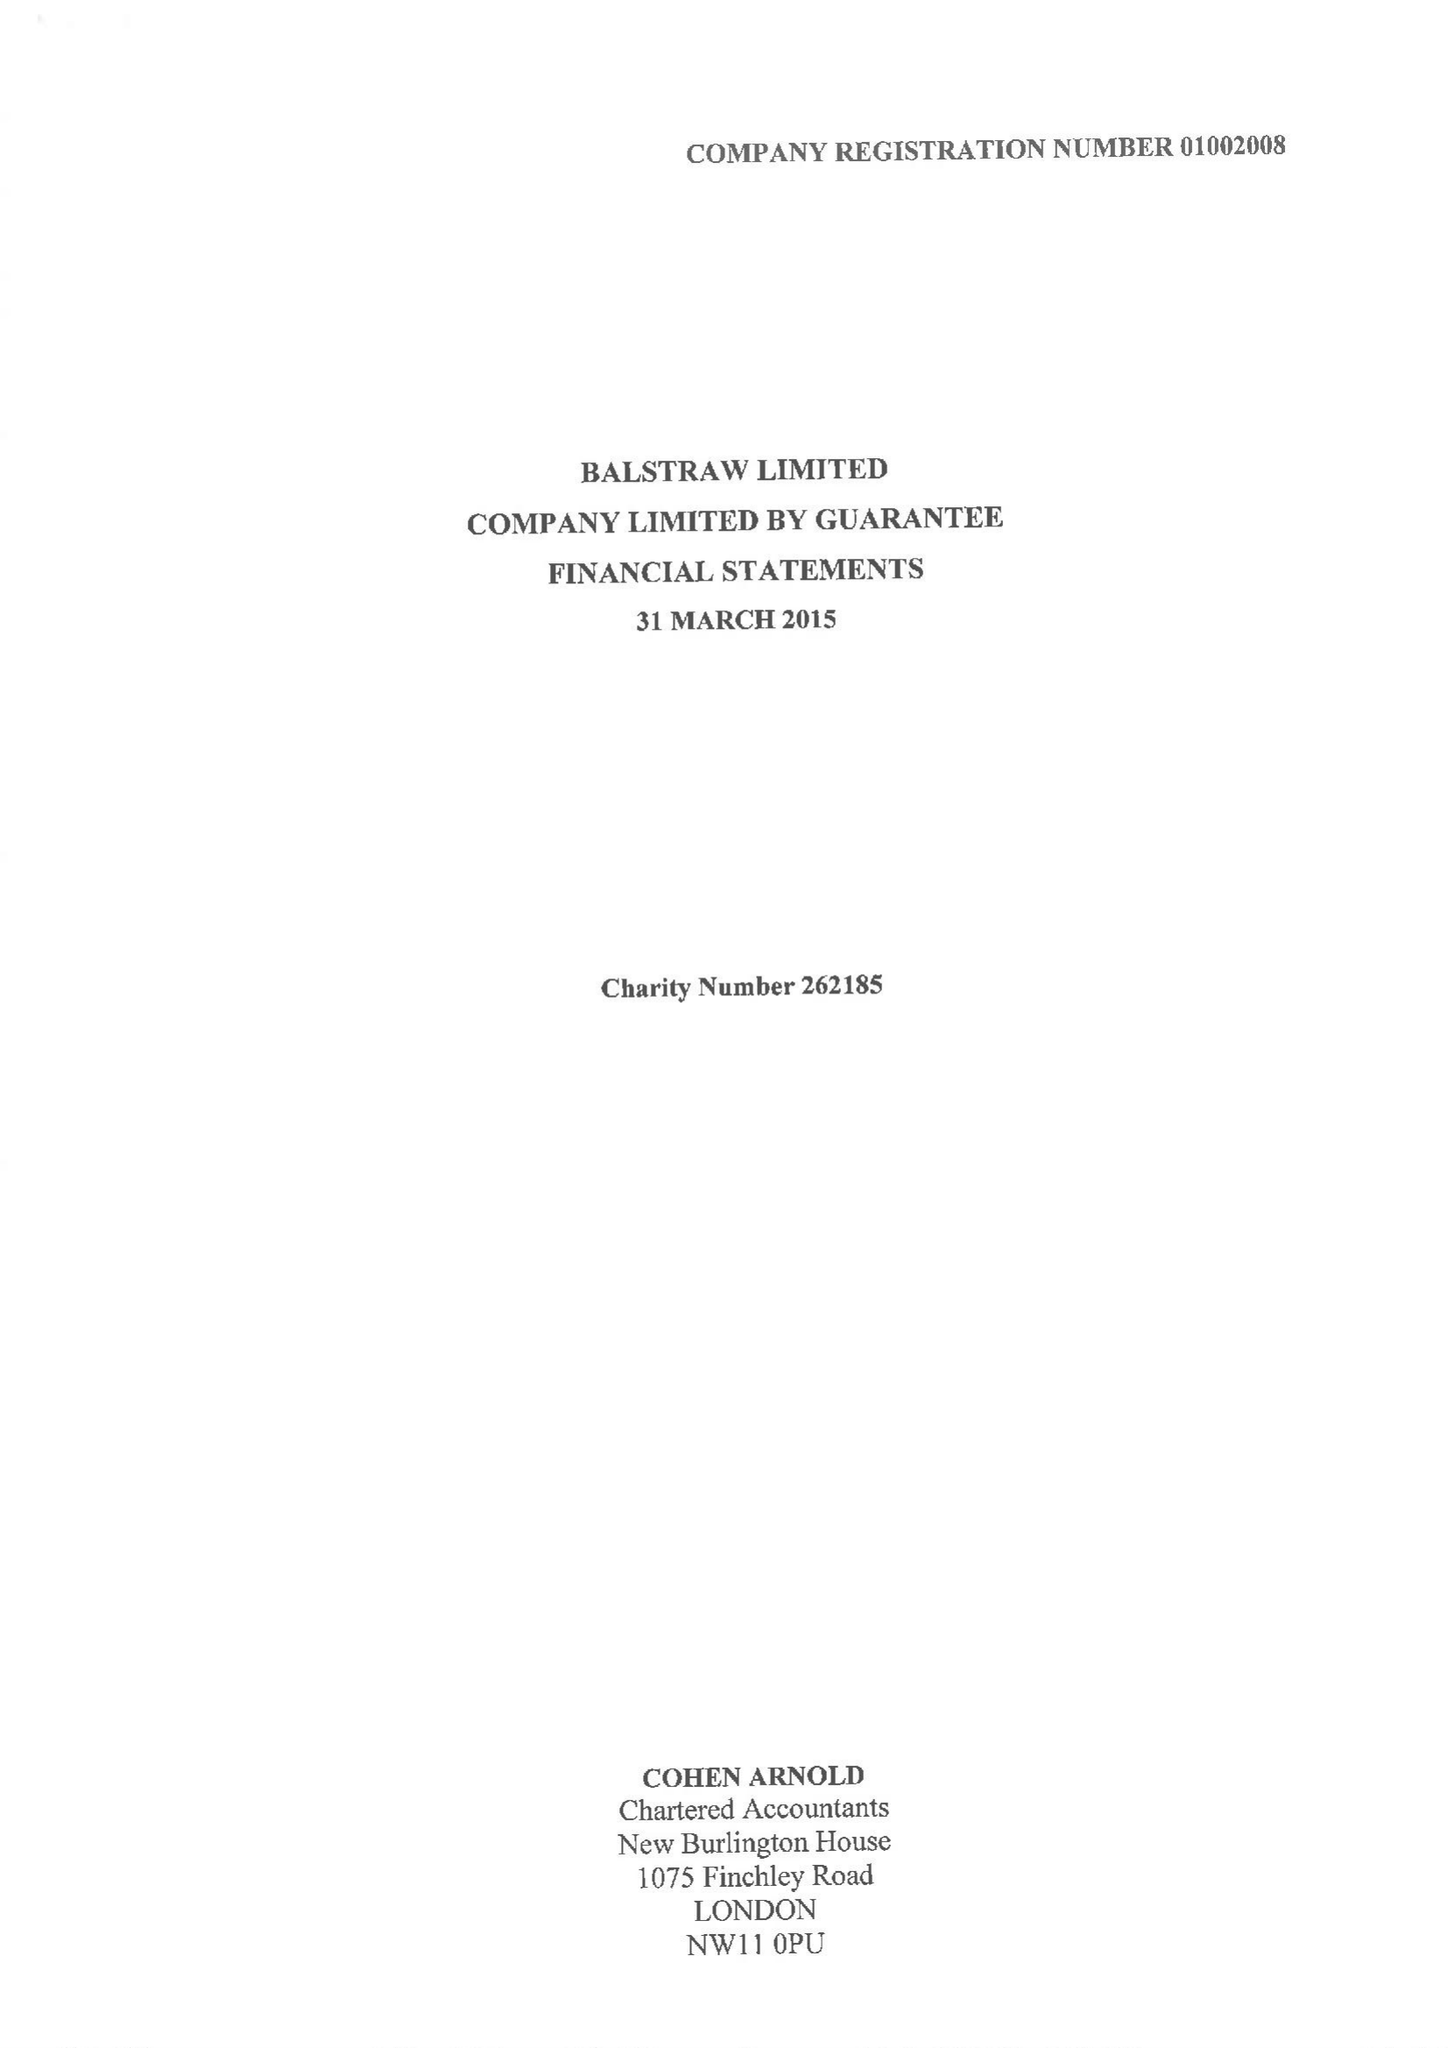What is the value for the address__postcode?
Answer the question using a single word or phrase. NW11 0PU 